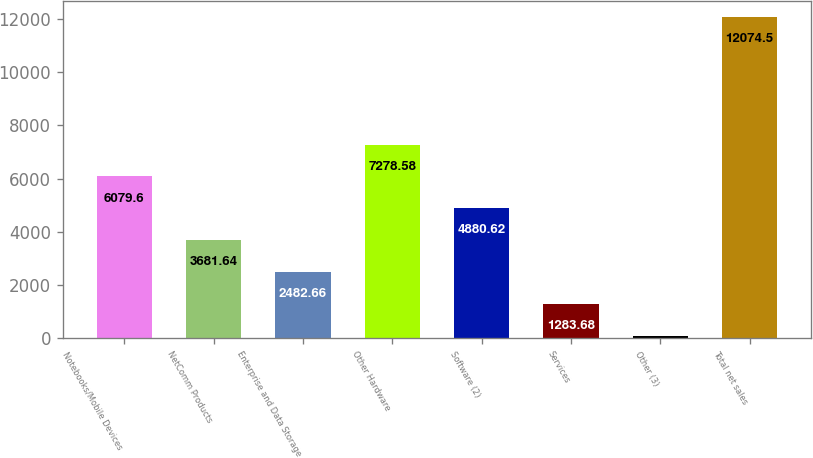<chart> <loc_0><loc_0><loc_500><loc_500><bar_chart><fcel>Notebooks/Mobile Devices<fcel>NetComm Products<fcel>Enterprise and Data Storage<fcel>Other Hardware<fcel>Software (2)<fcel>Services<fcel>Other (3)<fcel>Total net sales<nl><fcel>6079.6<fcel>3681.64<fcel>2482.66<fcel>7278.58<fcel>4880.62<fcel>1283.68<fcel>84.7<fcel>12074.5<nl></chart> 